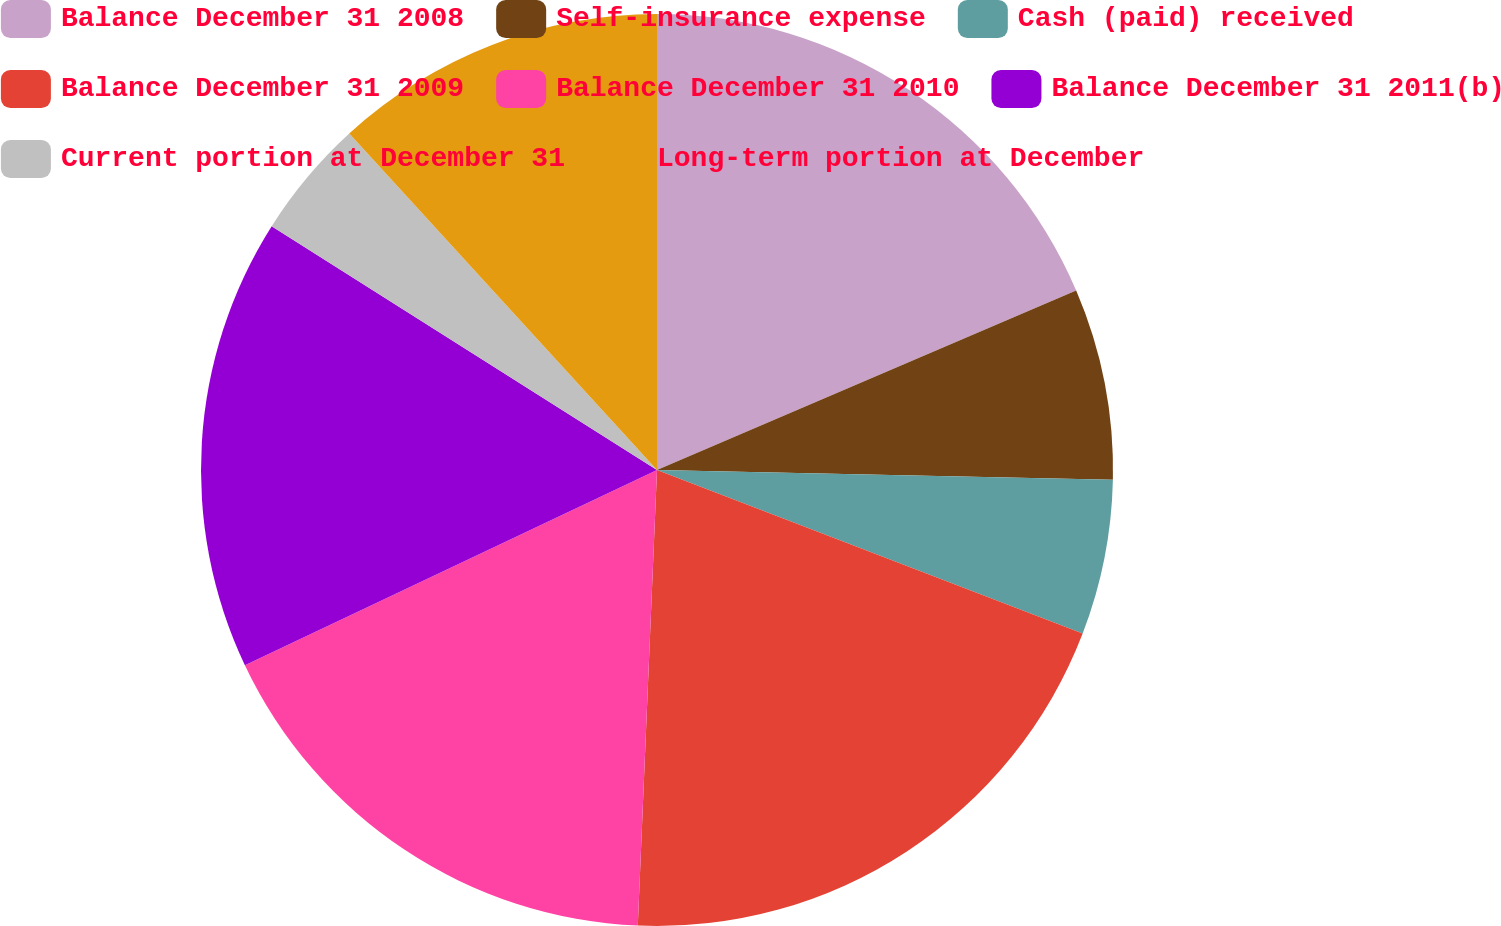Convert chart to OTSL. <chart><loc_0><loc_0><loc_500><loc_500><pie_chart><fcel>Balance December 31 2008<fcel>Self-insurance expense<fcel>Cash (paid) received<fcel>Balance December 31 2009<fcel>Balance December 31 2010<fcel>Balance December 31 2011(b)<fcel>Current portion at December 31<fcel>Long-term portion at December<nl><fcel>18.56%<fcel>6.78%<fcel>5.5%<fcel>19.83%<fcel>17.29%<fcel>16.02%<fcel>4.23%<fcel>11.79%<nl></chart> 